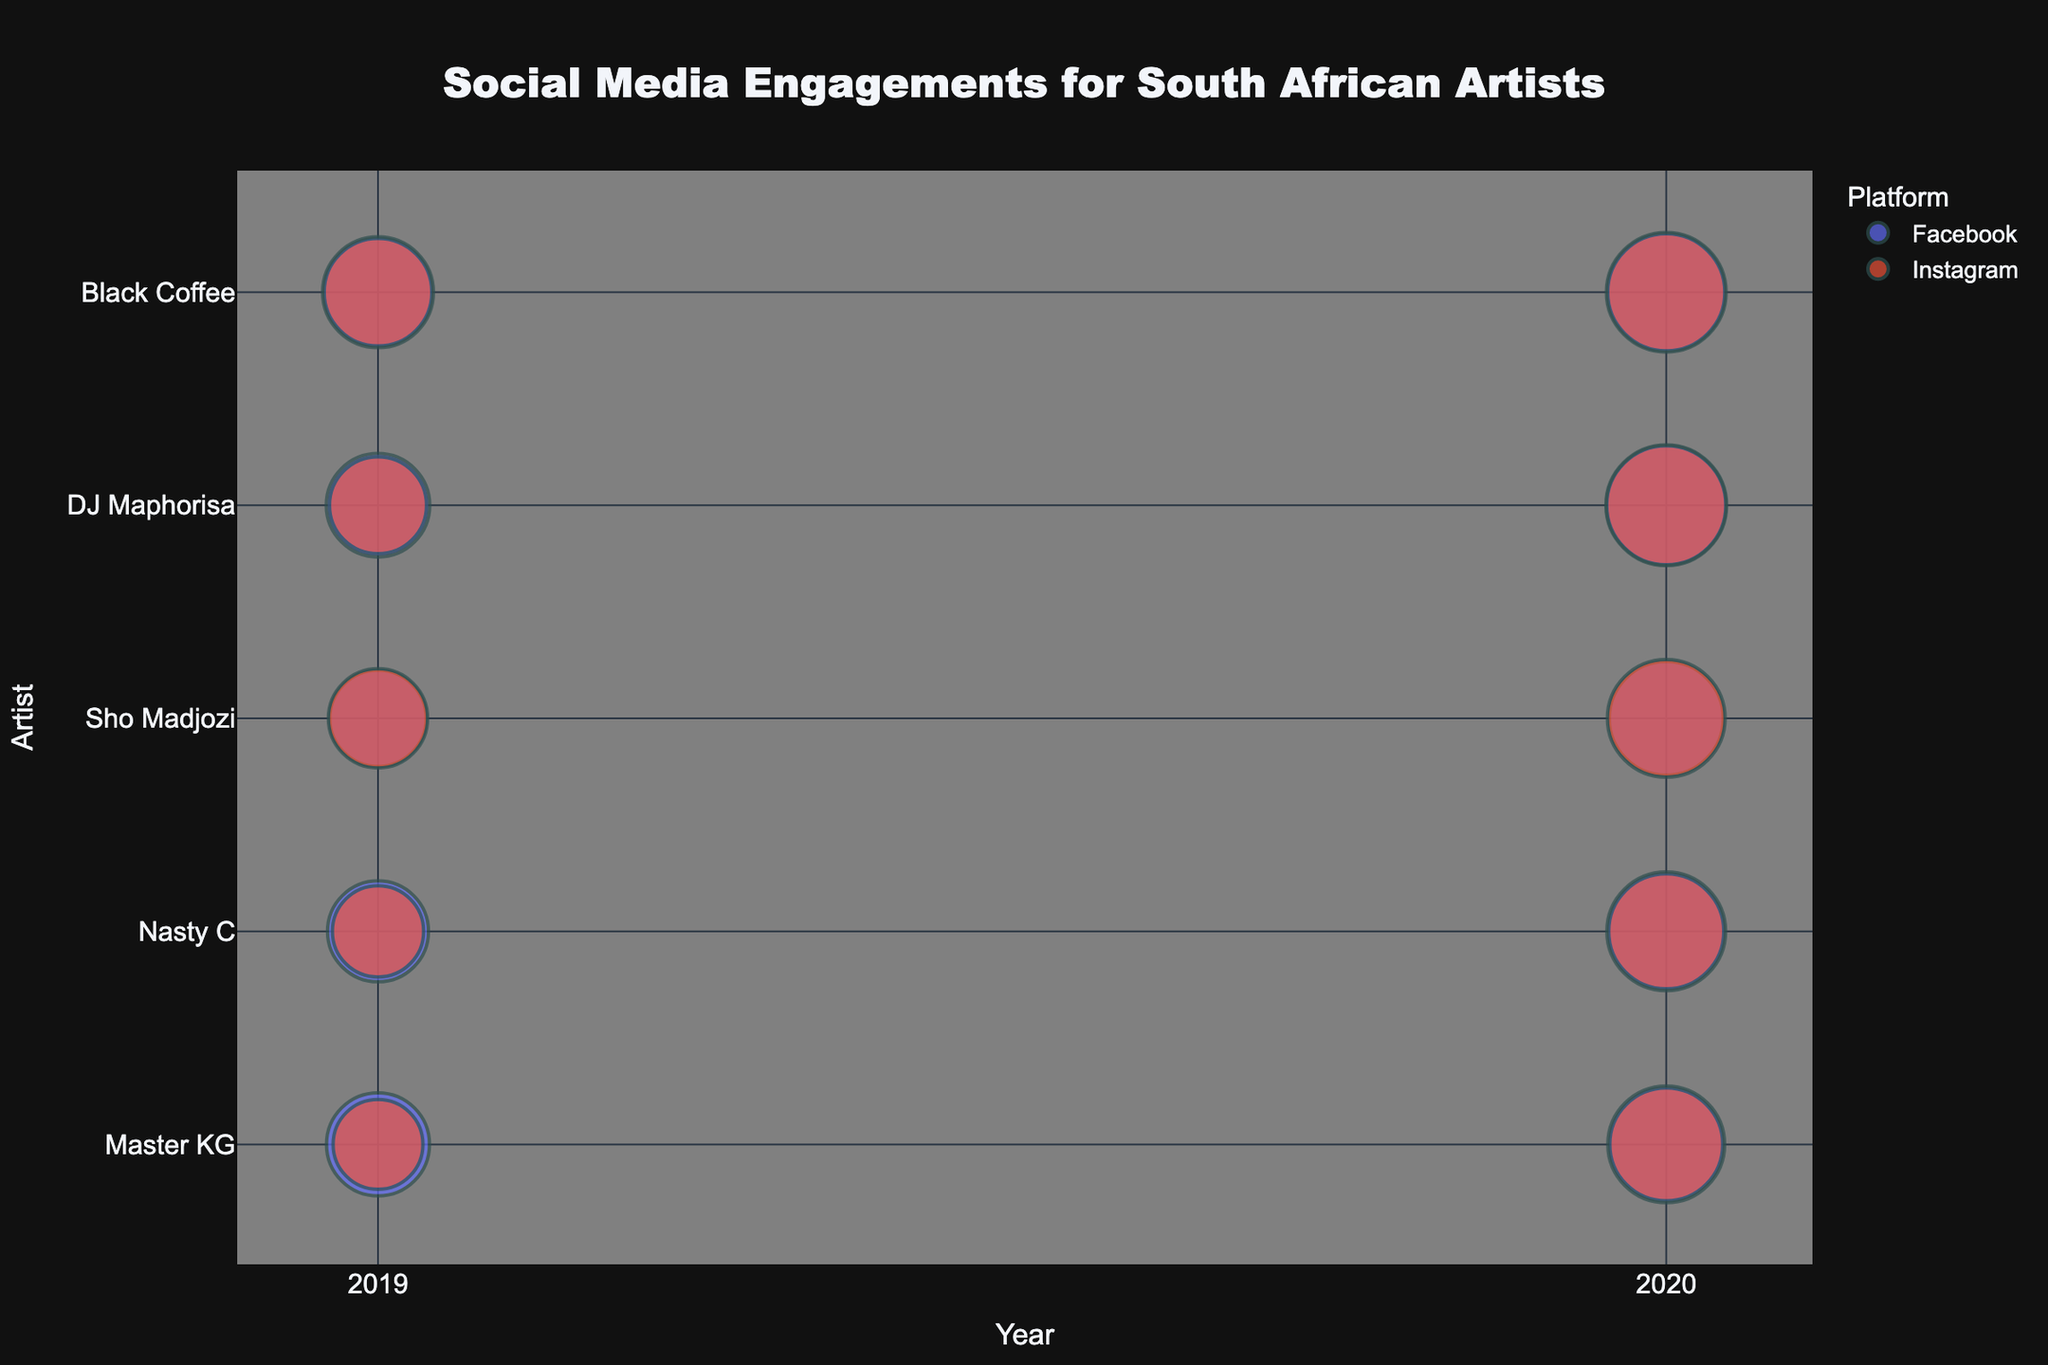what is the title of the chart? The title of the chart is displayed at the top of the bubble chart and reads "Social Media Engagements for South African Artists."
Answer: Social Media Engagements for South African Artists Which year had higher social media engagements for Master KG on Instagram? Look at the bubbles corresponding to Master KG and Instagram for both 2019 and 2020. The bubble size for 2020 is larger, indicating higher engagements.
Answer: 2020 How many artists are displayed in the chart? Count the unique names on the y-axis of the chart. The artists listed are Master KG, Nasty C, Sho Madjozi, DJ Maphorisa, and Black Coffee, making a total of 5 artists.
Answer: 5 What platform had the highest engagements for DJ Maphorisa in 2020? Compare the bubble sizes for DJ Maphorisa in 2020 across both Facebook and Instagram. The Instagram bubble size is larger.
Answer: Instagram Compare the social media engagements between Nasty C and Sho Madjozi on Facebook in 2019. Who had more engagements? Look at the bubble sizes for Nasty C and Sho Madjozi on Facebook in 2019. Nasty C's bubble is slightly larger.
Answer: Nasty C What is the trend in social media engagements for Black Coffee from 2019 to 2020 on Facebook? Observe the change in bubble size for Black Coffee on Facebook from 2019 to 2020. The bubble size increases, indicating a rising trend.
Answer: Increasing Which artist had the smallest increase in Instagram engagements from 2019 to 2020? Compare the sizes of the bubbles for each artist on Instagram between 2019 and 2020. Master KG shows the smallest increase in bubble size.
Answer: Master KG How do the 2020 Facebook engagements of Master KG compare to those of Black Coffee? Compare the bubble sizes for Master KG and Black Coffee on Facebook in 2020. Black Coffee's bubble is slightly smaller than Master KG's bubble, indicating slightly lower engagements.
Answer: Slightly lower What is the difference in engagements on Instagram between Sho Madjozi and DJ Maphorisa in 2020? Subtract DJ Maphorisa's Instagram engagements in 2020 (930,000) from Sho Madjozi's Instagram engagements in 2020 (890,000), resulting in -40,000. Sho Madjozi has 40,000 fewer engagements than DJ Maphorisa.
Answer: 40,000 fewer 